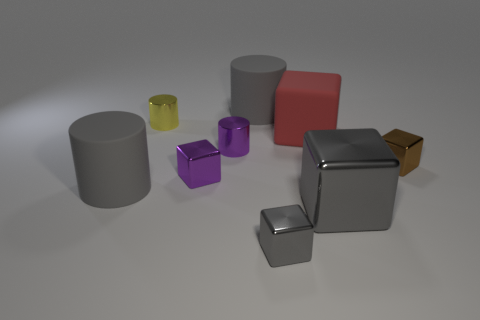Subtract all purple cubes. How many cubes are left? 4 Subtract all brown metal blocks. How many blocks are left? 4 Subtract all cyan cubes. Subtract all purple spheres. How many cubes are left? 5 Add 1 small gray shiny things. How many objects exist? 10 Subtract all cylinders. How many objects are left? 5 Add 6 big red matte cubes. How many big red matte cubes are left? 7 Add 6 big spheres. How many big spheres exist? 6 Subtract 0 cyan balls. How many objects are left? 9 Subtract all tiny purple cubes. Subtract all metal cubes. How many objects are left? 4 